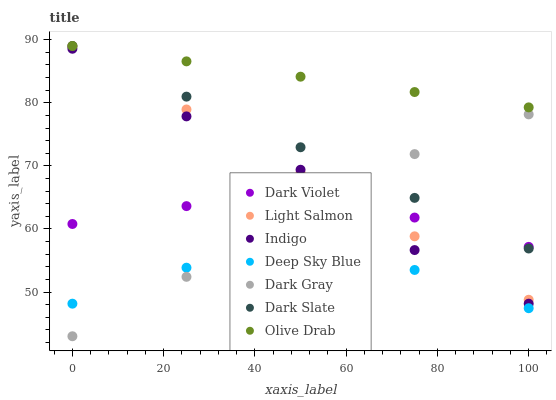Does Deep Sky Blue have the minimum area under the curve?
Answer yes or no. Yes. Does Olive Drab have the maximum area under the curve?
Answer yes or no. Yes. Does Indigo have the minimum area under the curve?
Answer yes or no. No. Does Indigo have the maximum area under the curve?
Answer yes or no. No. Is Light Salmon the smoothest?
Answer yes or no. Yes. Is Deep Sky Blue the roughest?
Answer yes or no. Yes. Is Indigo the smoothest?
Answer yes or no. No. Is Indigo the roughest?
Answer yes or no. No. Does Dark Gray have the lowest value?
Answer yes or no. Yes. Does Indigo have the lowest value?
Answer yes or no. No. Does Olive Drab have the highest value?
Answer yes or no. Yes. Does Indigo have the highest value?
Answer yes or no. No. Is Dark Gray less than Olive Drab?
Answer yes or no. Yes. Is Dark Slate greater than Deep Sky Blue?
Answer yes or no. Yes. Does Dark Violet intersect Dark Gray?
Answer yes or no. Yes. Is Dark Violet less than Dark Gray?
Answer yes or no. No. Is Dark Violet greater than Dark Gray?
Answer yes or no. No. Does Dark Gray intersect Olive Drab?
Answer yes or no. No. 